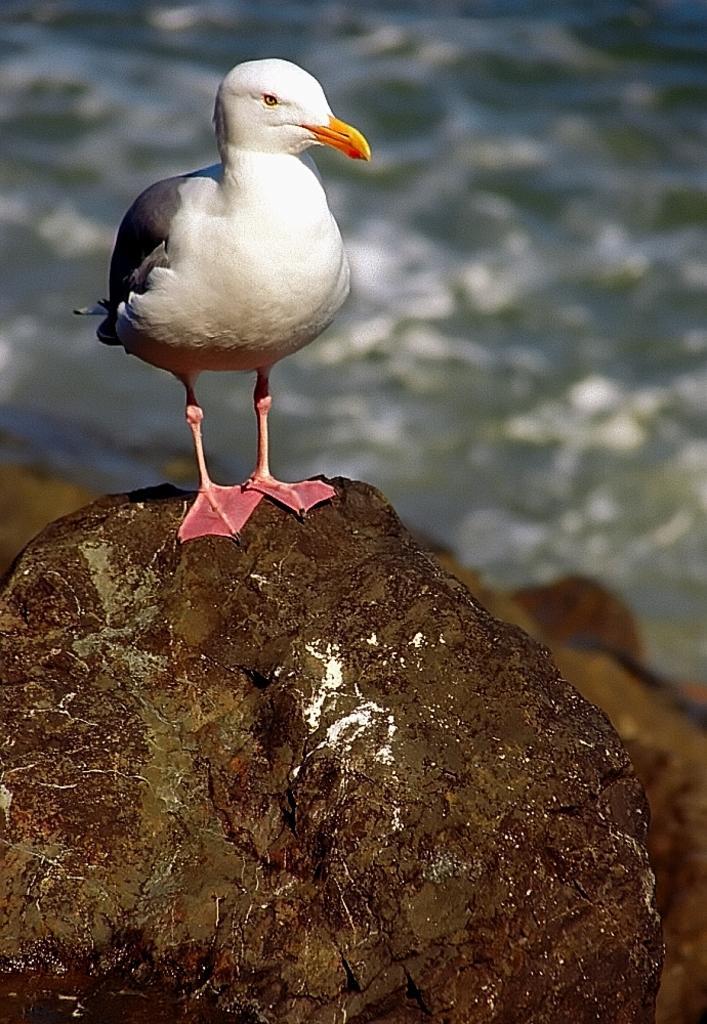In one or two sentences, can you explain what this image depicts? In this picture we can see a bird standing on a rock, in the background we can see water. 